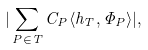<formula> <loc_0><loc_0><loc_500><loc_500>| \sum _ { P \in T } C _ { P } \langle h _ { T } , \Phi _ { P } \rangle | ,</formula> 